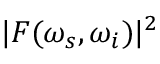<formula> <loc_0><loc_0><loc_500><loc_500>| F ( \omega _ { s } , \omega _ { i } ) | ^ { 2 }</formula> 